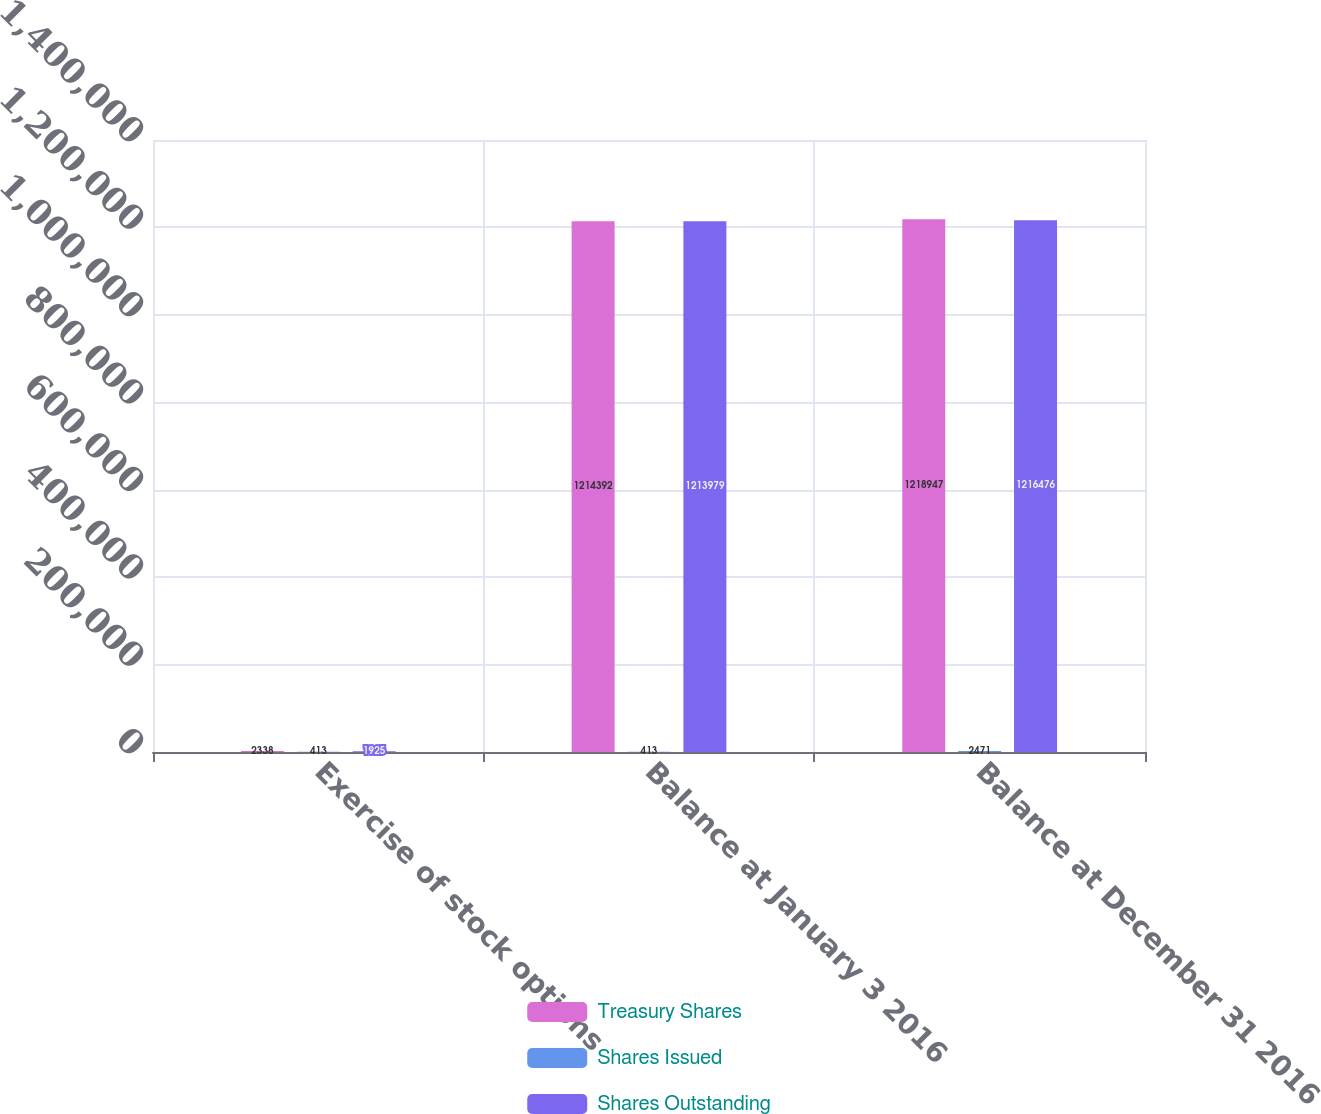Convert chart to OTSL. <chart><loc_0><loc_0><loc_500><loc_500><stacked_bar_chart><ecel><fcel>Exercise of stock options<fcel>Balance at January 3 2016<fcel>Balance at December 31 2016<nl><fcel>Treasury Shares<fcel>2338<fcel>1.21439e+06<fcel>1.21895e+06<nl><fcel>Shares Issued<fcel>413<fcel>413<fcel>2471<nl><fcel>Shares Outstanding<fcel>1925<fcel>1.21398e+06<fcel>1.21648e+06<nl></chart> 